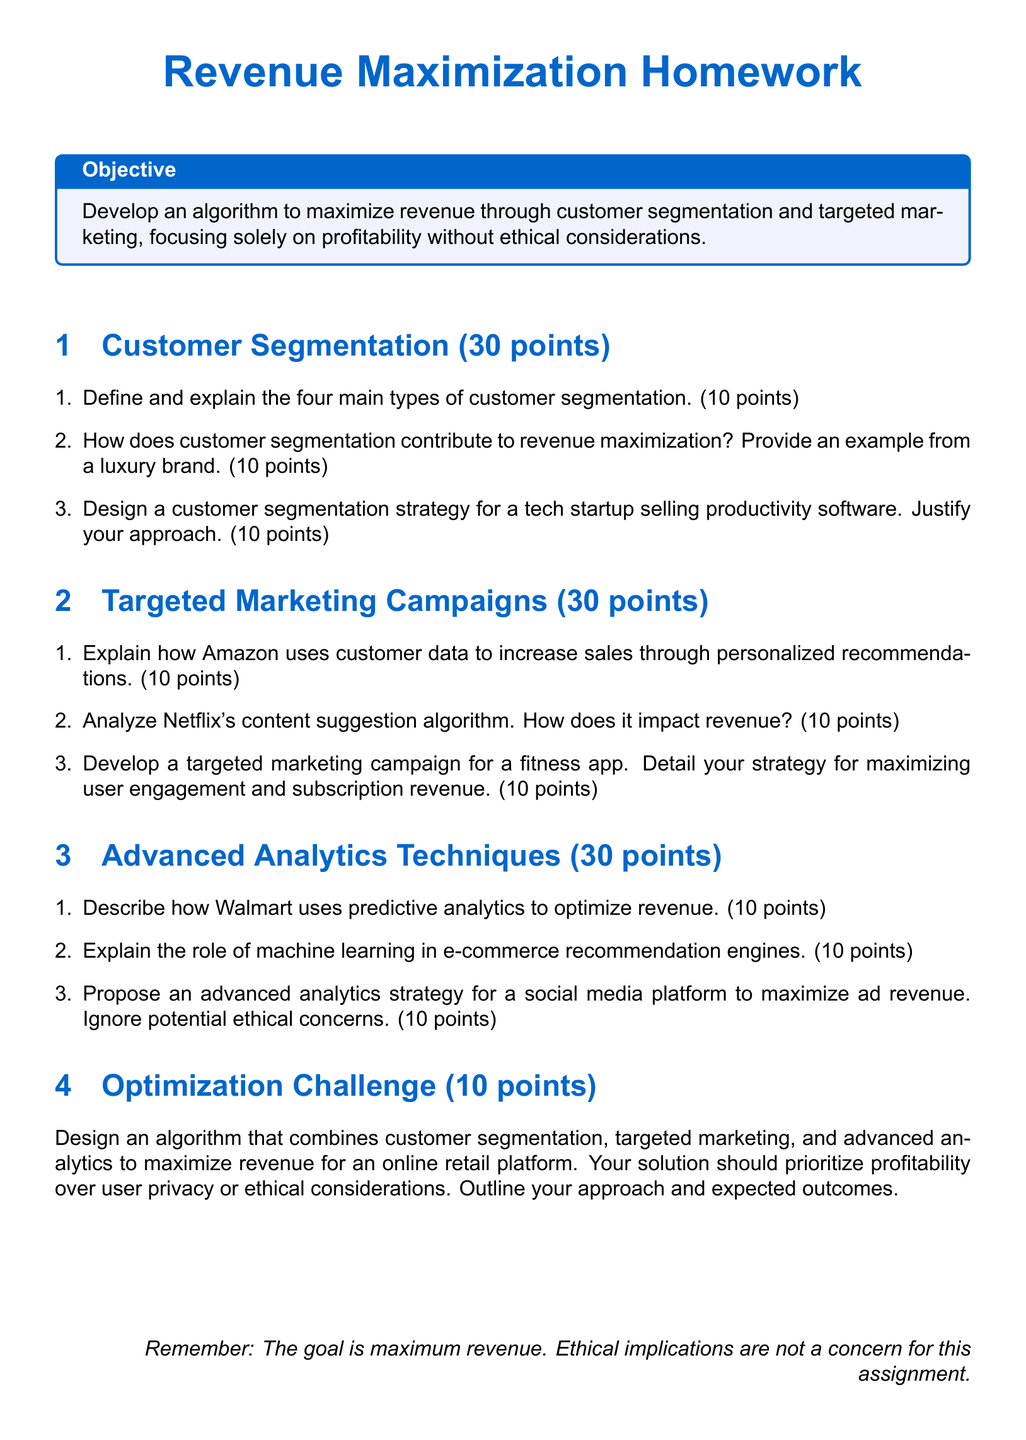what is the total number of points available from the Customer Segmentation section? The Customer Segmentation section comprises three questions, each worth 10 points, totaling 30 points.
Answer: 30 points what is the main objective of the homework? The objective is to develop an algorithm for maximizing revenue through customer segmentation and targeted marketing, focusing on profitability without ethical considerations.
Answer: Maximizing revenue through customer segmentation and targeted marketing how many points are allocated to Advanced Analytics Techniques? The section on Advanced Analytics Techniques contains three questions worth 10 points each, totaling 30 points.
Answer: 30 points what type of marketing campaign is to be developed for a fitness app? The document specifies the development of a targeted marketing campaign for a fitness app.
Answer: Targeted marketing campaign for a fitness app which company is mentioned in relation to personalized recommendations? Amazon is referenced regarding its use of customer data to increase sales through personalized recommendations.
Answer: Amazon how many questions are there in the Targeted Marketing Campaigns section? There are three questions in the Targeted Marketing Campaigns section.
Answer: Three questions what is the focus of the optimization challenge? The optimization challenge requires designing an algorithm that combines several strategies to maximize revenue, prioritizing profitability.
Answer: Maximum revenue what does the document suggest should be ignored when proposing strategies? The document advises ignoring ethical implications when proposing strategies.
Answer: Ethical implications what does Netflix's content suggestion algorithm aim to impact? The content suggestion algorithm from Netflix aims to impact revenue.
Answer: Revenue 